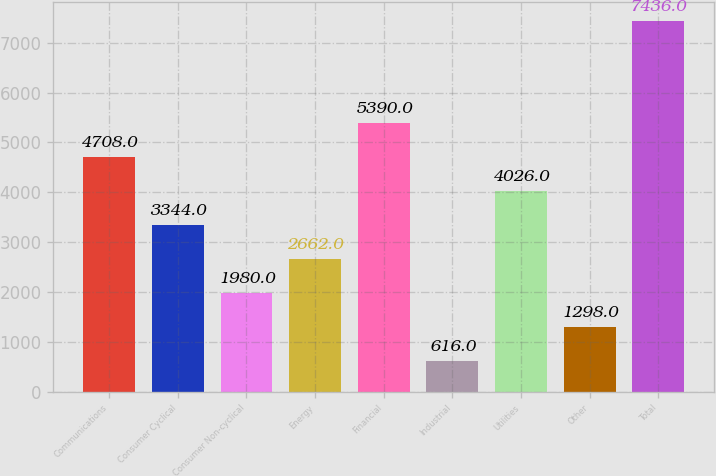Convert chart to OTSL. <chart><loc_0><loc_0><loc_500><loc_500><bar_chart><fcel>Communications<fcel>Consumer Cyclical<fcel>Consumer Non-cyclical<fcel>Energy<fcel>Financial<fcel>Industrial<fcel>Utilities<fcel>Other<fcel>Total<nl><fcel>4708<fcel>3344<fcel>1980<fcel>2662<fcel>5390<fcel>616<fcel>4026<fcel>1298<fcel>7436<nl></chart> 